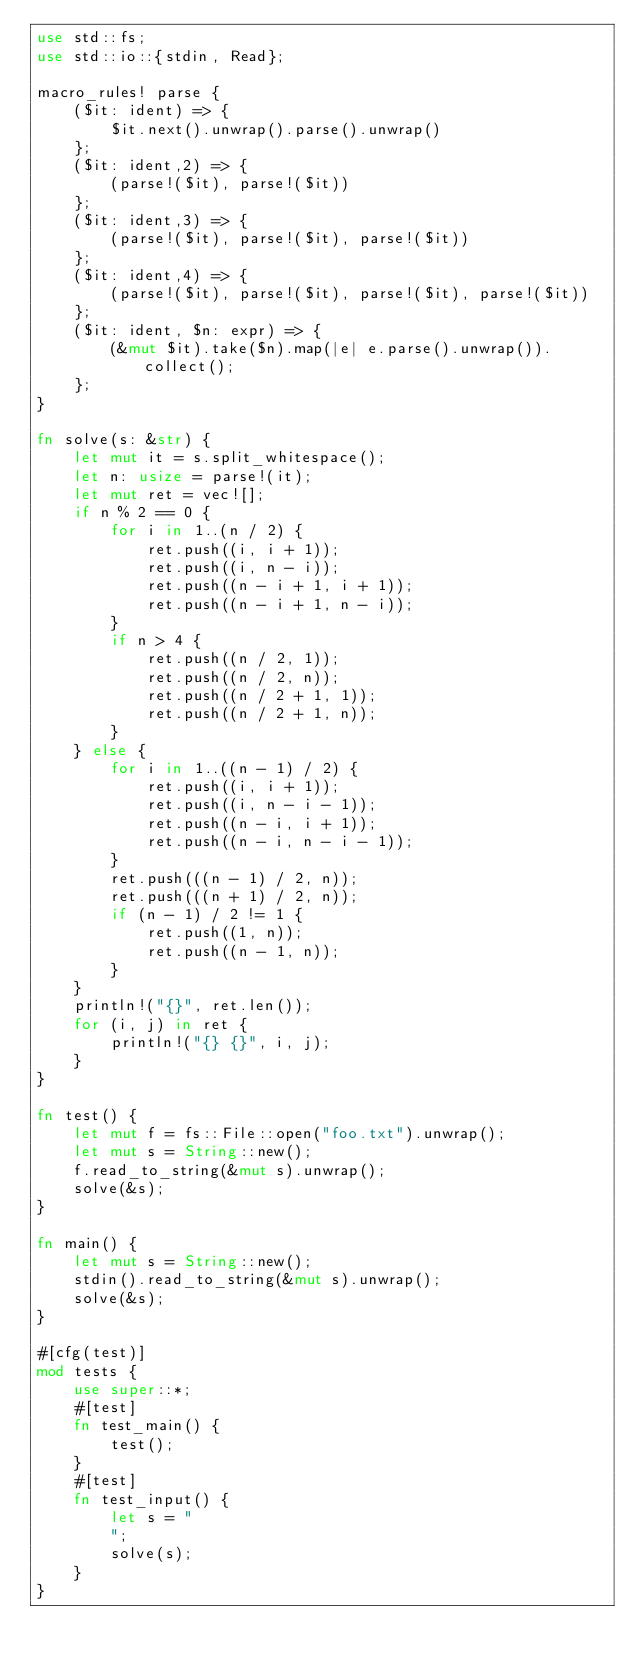<code> <loc_0><loc_0><loc_500><loc_500><_Rust_>use std::fs;
use std::io::{stdin, Read};

macro_rules! parse {
    ($it: ident) => {
        $it.next().unwrap().parse().unwrap()
    };
    ($it: ident,2) => {
        (parse!($it), parse!($it))
    };
    ($it: ident,3) => {
        (parse!($it), parse!($it), parse!($it))
    };
    ($it: ident,4) => {
        (parse!($it), parse!($it), parse!($it), parse!($it))
    };
    ($it: ident, $n: expr) => {
        (&mut $it).take($n).map(|e| e.parse().unwrap()).collect();
    };
}

fn solve(s: &str) {
    let mut it = s.split_whitespace();
    let n: usize = parse!(it);
    let mut ret = vec![];
    if n % 2 == 0 {
        for i in 1..(n / 2) {
            ret.push((i, i + 1));
            ret.push((i, n - i));
            ret.push((n - i + 1, i + 1));
            ret.push((n - i + 1, n - i));
        }
        if n > 4 {
            ret.push((n / 2, 1));
            ret.push((n / 2, n));
            ret.push((n / 2 + 1, 1));
            ret.push((n / 2 + 1, n));
        }
    } else {
        for i in 1..((n - 1) / 2) {
            ret.push((i, i + 1));
            ret.push((i, n - i - 1));
            ret.push((n - i, i + 1));
            ret.push((n - i, n - i - 1));
        }
        ret.push(((n - 1) / 2, n));
        ret.push(((n + 1) / 2, n));
        if (n - 1) / 2 != 1 {
            ret.push((1, n));
            ret.push((n - 1, n));
        }
    }
    println!("{}", ret.len());
    for (i, j) in ret {
        println!("{} {}", i, j);
    }
}

fn test() {
    let mut f = fs::File::open("foo.txt").unwrap();
    let mut s = String::new();
    f.read_to_string(&mut s).unwrap();
    solve(&s);
}

fn main() {
    let mut s = String::new();
    stdin().read_to_string(&mut s).unwrap();
    solve(&s);
}

#[cfg(test)]
mod tests {
    use super::*;
    #[test]
    fn test_main() {
        test();
    }
    #[test]
    fn test_input() {
        let s = "
        ";
        solve(s);
    }
}
</code> 